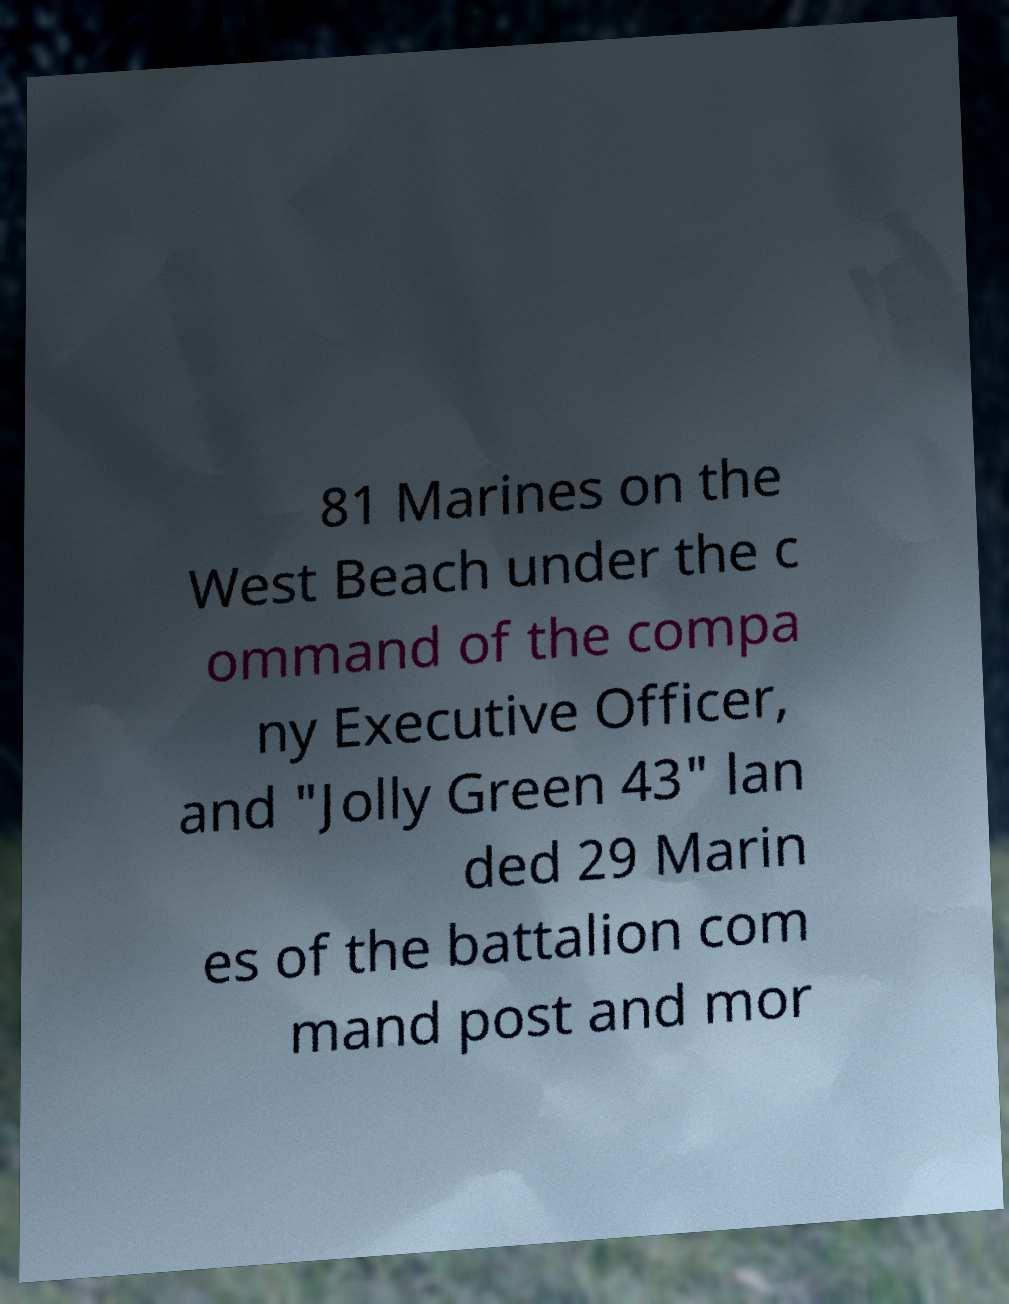For documentation purposes, I need the text within this image transcribed. Could you provide that? 81 Marines on the West Beach under the c ommand of the compa ny Executive Officer, and "Jolly Green 43" lan ded 29 Marin es of the battalion com mand post and mor 